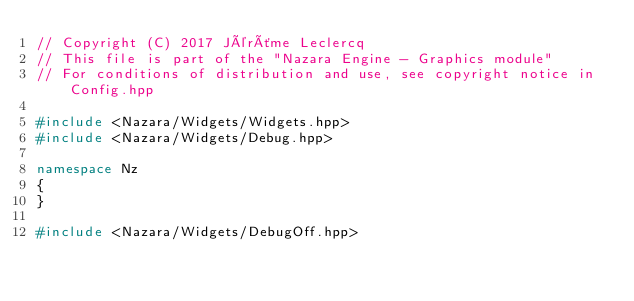Convert code to text. <code><loc_0><loc_0><loc_500><loc_500><_C++_>// Copyright (C) 2017 Jérôme Leclercq
// This file is part of the "Nazara Engine - Graphics module"
// For conditions of distribution and use, see copyright notice in Config.hpp

#include <Nazara/Widgets/Widgets.hpp>
#include <Nazara/Widgets/Debug.hpp>

namespace Nz
{
}

#include <Nazara/Widgets/DebugOff.hpp>
</code> 